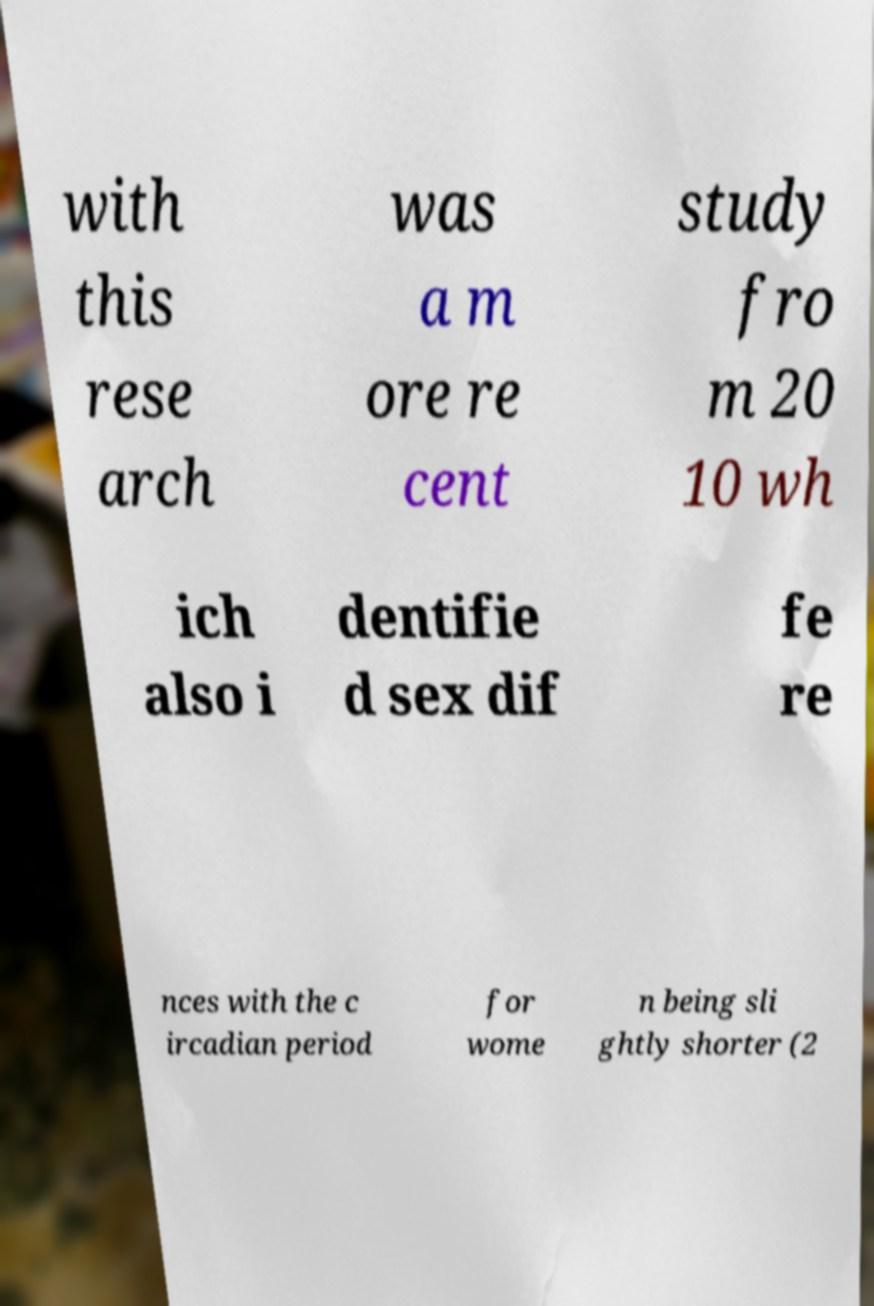Please read and relay the text visible in this image. What does it say? with this rese arch was a m ore re cent study fro m 20 10 wh ich also i dentifie d sex dif fe re nces with the c ircadian period for wome n being sli ghtly shorter (2 